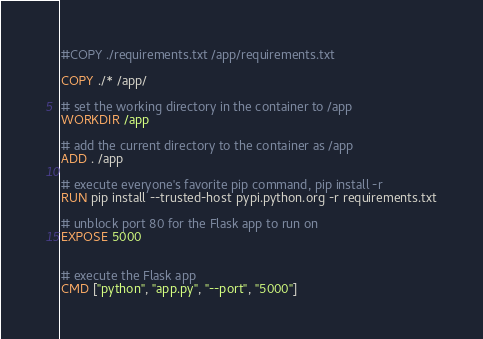<code> <loc_0><loc_0><loc_500><loc_500><_Dockerfile_>
#COPY ./requirements.txt /app/requirements.txt

COPY ./* /app/

# set the working directory in the container to /app
WORKDIR /app

# add the current directory to the container as /app
ADD . /app

# execute everyone's favorite pip command, pip install -r
RUN pip install --trusted-host pypi.python.org -r requirements.txt

# unblock port 80 for the Flask app to run on
EXPOSE 5000


# execute the Flask app
CMD ["python", "app.py", "--port", "5000"]

</code> 